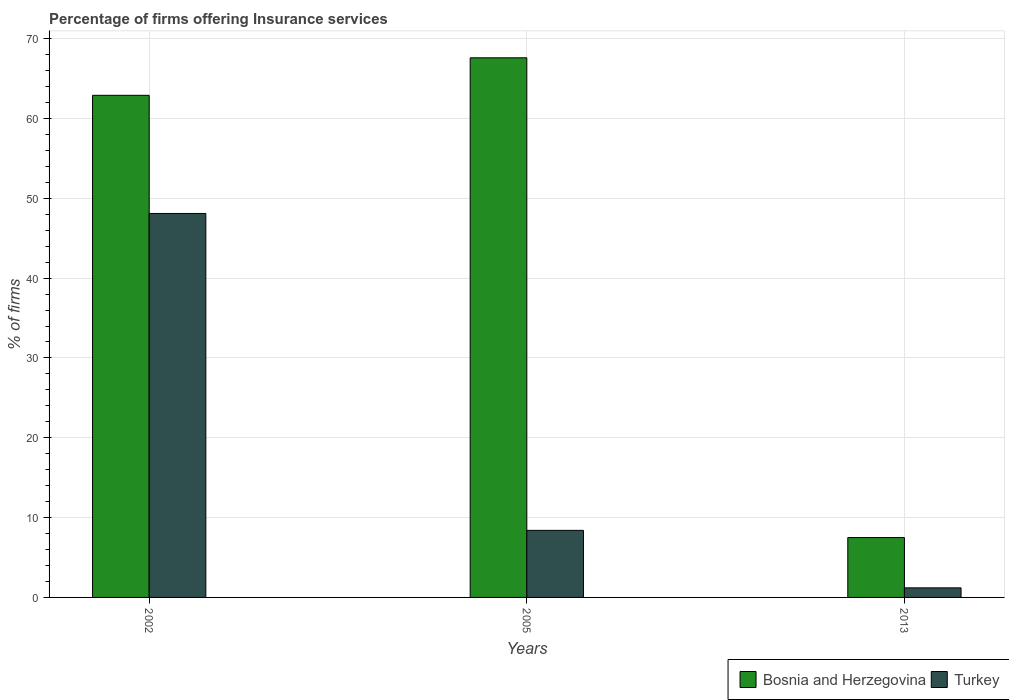How many different coloured bars are there?
Your answer should be very brief. 2. Are the number of bars on each tick of the X-axis equal?
Ensure brevity in your answer.  Yes. How many bars are there on the 1st tick from the right?
Keep it short and to the point. 2. What is the label of the 2nd group of bars from the left?
Your response must be concise. 2005. In how many cases, is the number of bars for a given year not equal to the number of legend labels?
Make the answer very short. 0. What is the percentage of firms offering insurance services in Turkey in 2002?
Your answer should be compact. 48.1. Across all years, what is the maximum percentage of firms offering insurance services in Turkey?
Offer a very short reply. 48.1. Across all years, what is the minimum percentage of firms offering insurance services in Bosnia and Herzegovina?
Your response must be concise. 7.5. In which year was the percentage of firms offering insurance services in Turkey maximum?
Keep it short and to the point. 2002. What is the total percentage of firms offering insurance services in Turkey in the graph?
Provide a succinct answer. 57.7. What is the difference between the percentage of firms offering insurance services in Bosnia and Herzegovina in 2002 and that in 2013?
Ensure brevity in your answer.  55.4. What is the difference between the percentage of firms offering insurance services in Turkey in 2005 and the percentage of firms offering insurance services in Bosnia and Herzegovina in 2002?
Provide a short and direct response. -54.5. In the year 2005, what is the difference between the percentage of firms offering insurance services in Bosnia and Herzegovina and percentage of firms offering insurance services in Turkey?
Your response must be concise. 59.2. In how many years, is the percentage of firms offering insurance services in Bosnia and Herzegovina greater than 14 %?
Make the answer very short. 2. What is the ratio of the percentage of firms offering insurance services in Bosnia and Herzegovina in 2002 to that in 2005?
Your answer should be compact. 0.93. Is the percentage of firms offering insurance services in Turkey in 2005 less than that in 2013?
Provide a succinct answer. No. Is the difference between the percentage of firms offering insurance services in Bosnia and Herzegovina in 2005 and 2013 greater than the difference between the percentage of firms offering insurance services in Turkey in 2005 and 2013?
Give a very brief answer. Yes. What is the difference between the highest and the second highest percentage of firms offering insurance services in Turkey?
Provide a short and direct response. 39.7. What is the difference between the highest and the lowest percentage of firms offering insurance services in Bosnia and Herzegovina?
Make the answer very short. 60.1. What does the 1st bar from the left in 2005 represents?
Ensure brevity in your answer.  Bosnia and Herzegovina. What does the 1st bar from the right in 2005 represents?
Offer a terse response. Turkey. How many bars are there?
Your answer should be very brief. 6. Are all the bars in the graph horizontal?
Offer a very short reply. No. What is the difference between two consecutive major ticks on the Y-axis?
Ensure brevity in your answer.  10. Does the graph contain grids?
Provide a succinct answer. Yes. Where does the legend appear in the graph?
Make the answer very short. Bottom right. How are the legend labels stacked?
Provide a succinct answer. Horizontal. What is the title of the graph?
Offer a very short reply. Percentage of firms offering Insurance services. Does "Upper middle income" appear as one of the legend labels in the graph?
Give a very brief answer. No. What is the label or title of the X-axis?
Offer a very short reply. Years. What is the label or title of the Y-axis?
Offer a very short reply. % of firms. What is the % of firms of Bosnia and Herzegovina in 2002?
Your answer should be compact. 62.9. What is the % of firms in Turkey in 2002?
Offer a terse response. 48.1. What is the % of firms of Bosnia and Herzegovina in 2005?
Your answer should be very brief. 67.6. What is the % of firms of Turkey in 2005?
Offer a very short reply. 8.4. What is the % of firms in Turkey in 2013?
Provide a short and direct response. 1.2. Across all years, what is the maximum % of firms in Bosnia and Herzegovina?
Give a very brief answer. 67.6. Across all years, what is the maximum % of firms in Turkey?
Your answer should be very brief. 48.1. Across all years, what is the minimum % of firms in Turkey?
Your answer should be compact. 1.2. What is the total % of firms in Bosnia and Herzegovina in the graph?
Your response must be concise. 138. What is the total % of firms of Turkey in the graph?
Your answer should be very brief. 57.7. What is the difference between the % of firms of Bosnia and Herzegovina in 2002 and that in 2005?
Ensure brevity in your answer.  -4.7. What is the difference between the % of firms of Turkey in 2002 and that in 2005?
Give a very brief answer. 39.7. What is the difference between the % of firms in Bosnia and Herzegovina in 2002 and that in 2013?
Provide a short and direct response. 55.4. What is the difference between the % of firms in Turkey in 2002 and that in 2013?
Your answer should be very brief. 46.9. What is the difference between the % of firms of Bosnia and Herzegovina in 2005 and that in 2013?
Offer a terse response. 60.1. What is the difference between the % of firms in Bosnia and Herzegovina in 2002 and the % of firms in Turkey in 2005?
Keep it short and to the point. 54.5. What is the difference between the % of firms of Bosnia and Herzegovina in 2002 and the % of firms of Turkey in 2013?
Make the answer very short. 61.7. What is the difference between the % of firms in Bosnia and Herzegovina in 2005 and the % of firms in Turkey in 2013?
Give a very brief answer. 66.4. What is the average % of firms of Bosnia and Herzegovina per year?
Your answer should be very brief. 46. What is the average % of firms of Turkey per year?
Provide a succinct answer. 19.23. In the year 2005, what is the difference between the % of firms of Bosnia and Herzegovina and % of firms of Turkey?
Your response must be concise. 59.2. What is the ratio of the % of firms of Bosnia and Herzegovina in 2002 to that in 2005?
Ensure brevity in your answer.  0.93. What is the ratio of the % of firms of Turkey in 2002 to that in 2005?
Make the answer very short. 5.73. What is the ratio of the % of firms of Bosnia and Herzegovina in 2002 to that in 2013?
Provide a short and direct response. 8.39. What is the ratio of the % of firms of Turkey in 2002 to that in 2013?
Provide a succinct answer. 40.08. What is the ratio of the % of firms in Bosnia and Herzegovina in 2005 to that in 2013?
Offer a terse response. 9.01. What is the ratio of the % of firms of Turkey in 2005 to that in 2013?
Give a very brief answer. 7. What is the difference between the highest and the second highest % of firms of Bosnia and Herzegovina?
Provide a short and direct response. 4.7. What is the difference between the highest and the second highest % of firms of Turkey?
Provide a short and direct response. 39.7. What is the difference between the highest and the lowest % of firms of Bosnia and Herzegovina?
Make the answer very short. 60.1. What is the difference between the highest and the lowest % of firms in Turkey?
Your answer should be compact. 46.9. 